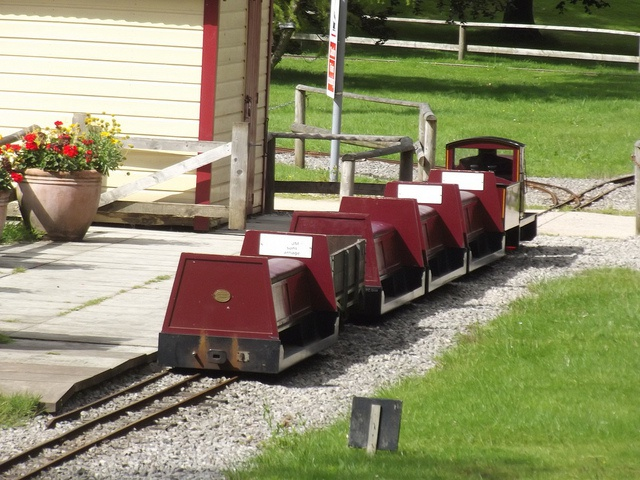Describe the objects in this image and their specific colors. I can see train in gray, maroon, black, and white tones and potted plant in gray, olive, tan, and black tones in this image. 